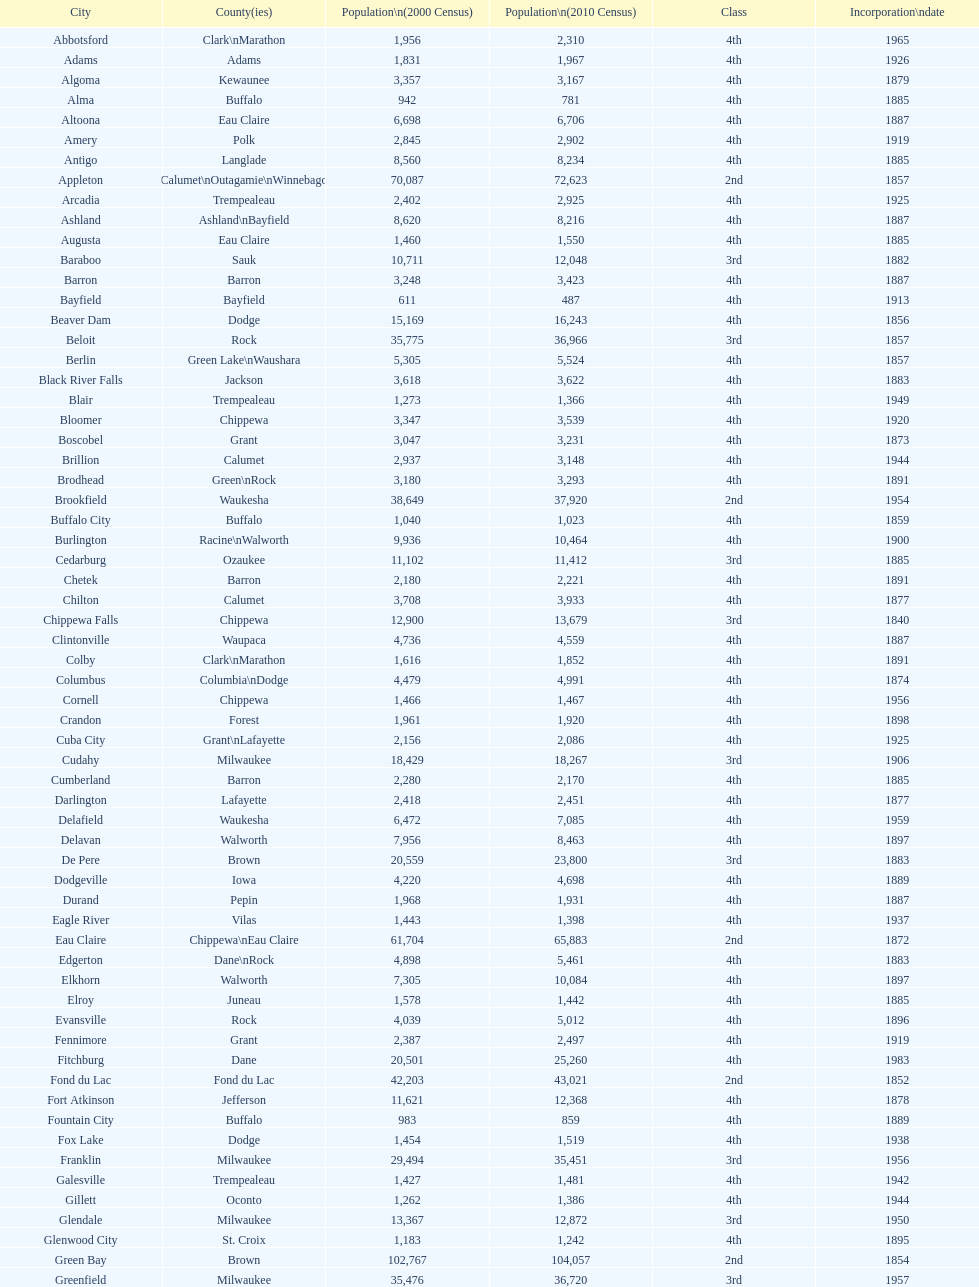What is the number of cities in wisconsin? 190. 